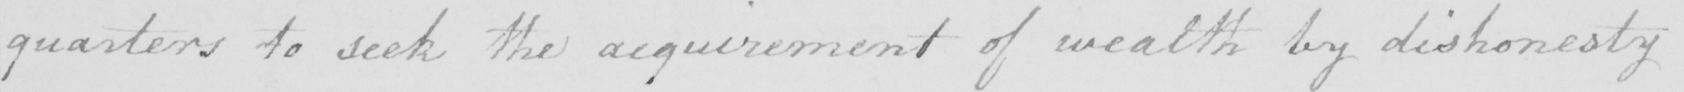What is written in this line of handwriting? quarters to seek the acquirement of wealth by dishonesty 